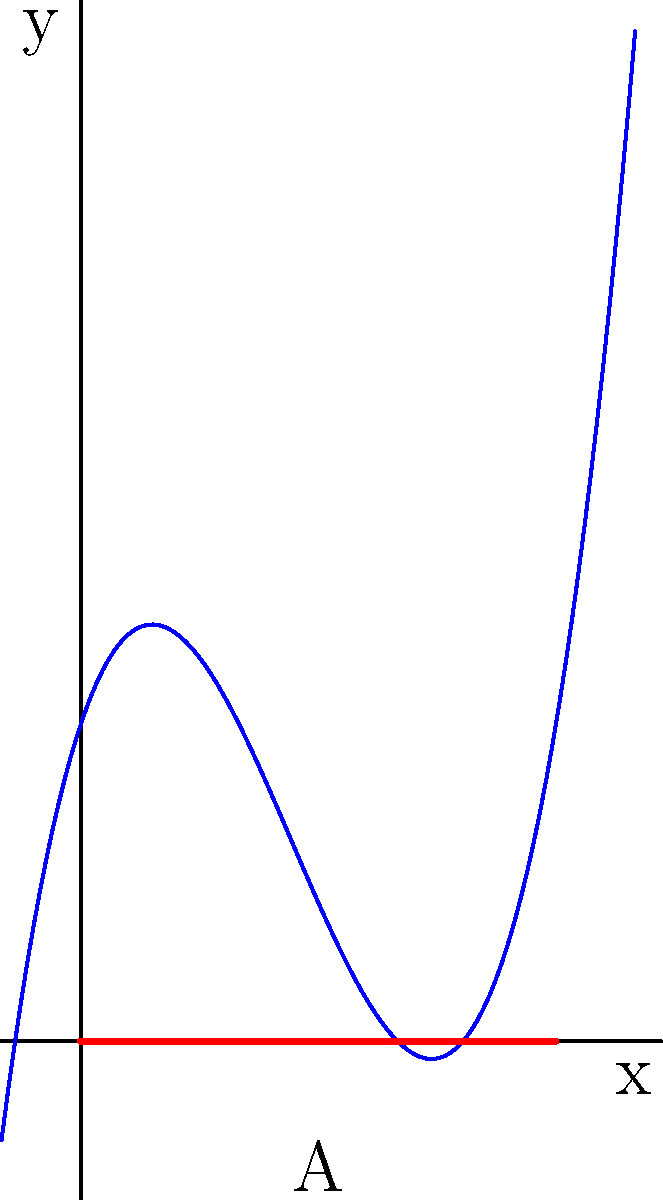As a technological coach, you're designing a computer simulation to demonstrate area calculations. The simulation shows a curve represented by the function $f(x) = x^3 - 4x^2 + 3x + 2$. Calculate the area (A) between this curve and the x-axis from x = 0 to x = 3, which represents the efficiency of a new algorithm you're developing. Round your answer to two decimal places. To find the area between the curve and the x-axis, we need to integrate the function over the given interval and take the absolute value. Here's the step-by-step process:

1) The area is given by the definite integral:
   $$A = \int_0^3 |f(x)| dx = \int_0^3 |x^3 - 4x^2 + 3x + 2| dx$$

2) To solve this, we need to find the roots of the function in the interval [0, 3]:
   Setting $f(x) = 0$:
   $x^3 - 4x^2 + 3x + 2 = 0$
   The roots are approximately 0.38 and 2.88 (the third root is outside our interval)

3) This divides our integral into three parts:
   $$A = \int_0^{0.38} -(x^3 - 4x^2 + 3x + 2) dx + \int_{0.38}^{2.88} (x^3 - 4x^2 + 3x + 2) dx + \int_{2.88}^3 -(x^3 - 4x^2 + 3x + 2) dx$$

4) Integrate each part:
   $$A = [-\frac{x^4}{4} + \frac{4x^3}{3} - \frac{3x^2}{2} - 2x]_0^{0.38} + [\frac{x^4}{4} - \frac{4x^3}{3} + \frac{3x^2}{2} + 2x]_{0.38}^{2.88} + [-\frac{x^4}{4} + \frac{4x^3}{3} - \frac{3x^2}{2} - 2x]_{2.88}^3$$

5) Evaluate the integrals and sum the results:
   $A \approx 0.1037 + 2.7858 + 0.0027 = 2.8922$

6) Rounding to two decimal places:
   $A \approx 2.89$
Answer: 2.89 